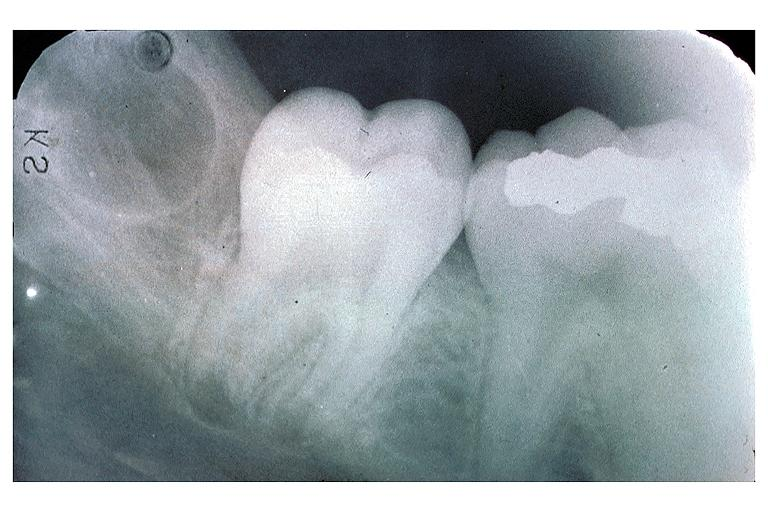where is this?
Answer the question using a single word or phrase. Oral 